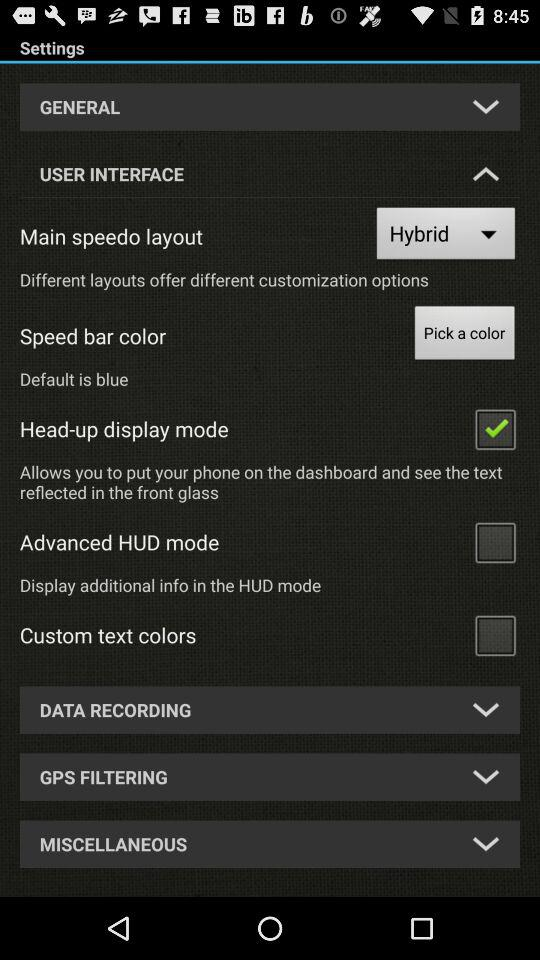What is the status of the Head-up display mode? The status is on. 